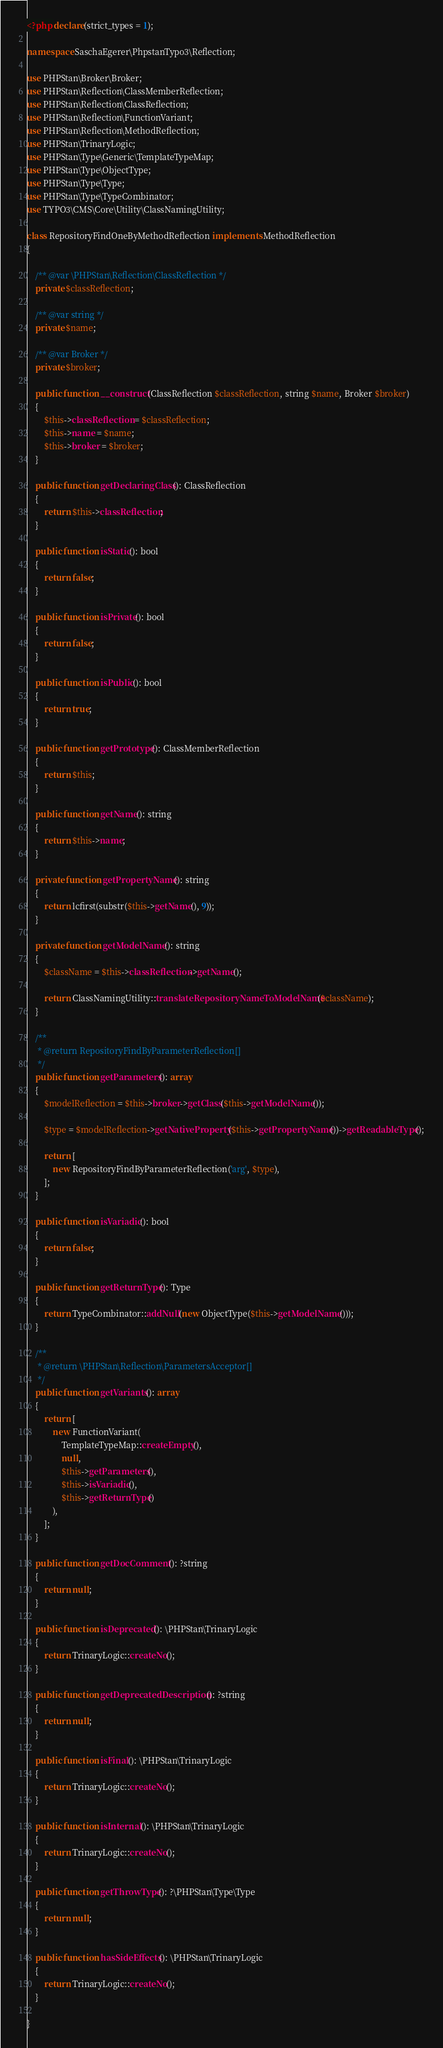<code> <loc_0><loc_0><loc_500><loc_500><_PHP_><?php declare(strict_types = 1);

namespace SaschaEgerer\PhpstanTypo3\Reflection;

use PHPStan\Broker\Broker;
use PHPStan\Reflection\ClassMemberReflection;
use PHPStan\Reflection\ClassReflection;
use PHPStan\Reflection\FunctionVariant;
use PHPStan\Reflection\MethodReflection;
use PHPStan\TrinaryLogic;
use PHPStan\Type\Generic\TemplateTypeMap;
use PHPStan\Type\ObjectType;
use PHPStan\Type\Type;
use PHPStan\Type\TypeCombinator;
use TYPO3\CMS\Core\Utility\ClassNamingUtility;

class RepositoryFindOneByMethodReflection implements MethodReflection
{

	/** @var \PHPStan\Reflection\ClassReflection */
	private $classReflection;

	/** @var string */
	private $name;

	/** @var Broker */
	private $broker;

	public function __construct(ClassReflection $classReflection, string $name, Broker $broker)
	{
		$this->classReflection = $classReflection;
		$this->name = $name;
		$this->broker = $broker;
	}

	public function getDeclaringClass(): ClassReflection
	{
		return $this->classReflection;
	}

	public function isStatic(): bool
	{
		return false;
	}

	public function isPrivate(): bool
	{
		return false;
	}

	public function isPublic(): bool
	{
		return true;
	}

	public function getPrototype(): ClassMemberReflection
	{
		return $this;
	}

	public function getName(): string
	{
		return $this->name;
	}

	private function getPropertyName(): string
	{
		return lcfirst(substr($this->getName(), 9));
	}

	private function getModelName(): string
	{
		$className = $this->classReflection->getName();

		return ClassNamingUtility::translateRepositoryNameToModelName($className);
	}

	/**
	 * @return RepositoryFindByParameterReflection[]
	 */
	public function getParameters(): array
	{
		$modelReflection = $this->broker->getClass($this->getModelName());

		$type = $modelReflection->getNativeProperty($this->getPropertyName())->getReadableType();

		return [
			new RepositoryFindByParameterReflection('arg', $type),
		];
	}

	public function isVariadic(): bool
	{
		return false;
	}

	public function getReturnType(): Type
	{
		return TypeCombinator::addNull(new ObjectType($this->getModelName()));
	}

	/**
	 * @return \PHPStan\Reflection\ParametersAcceptor[]
	 */
	public function getVariants(): array
	{
		return [
			new FunctionVariant(
				TemplateTypeMap::createEmpty(),
				null,
				$this->getParameters(),
				$this->isVariadic(),
				$this->getReturnType()
			),
		];
	}

	public function getDocComment(): ?string
	{
		return null;
	}

	public function isDeprecated(): \PHPStan\TrinaryLogic
	{
		return TrinaryLogic::createNo();
	}

	public function getDeprecatedDescription(): ?string
	{
		return null;
	}

	public function isFinal(): \PHPStan\TrinaryLogic
	{
		return TrinaryLogic::createNo();
	}

	public function isInternal(): \PHPStan\TrinaryLogic
	{
		return TrinaryLogic::createNo();
	}

	public function getThrowType(): ?\PHPStan\Type\Type
	{
		return null;
	}

	public function hasSideEffects(): \PHPStan\TrinaryLogic
	{
		return TrinaryLogic::createNo();
	}

}
</code> 